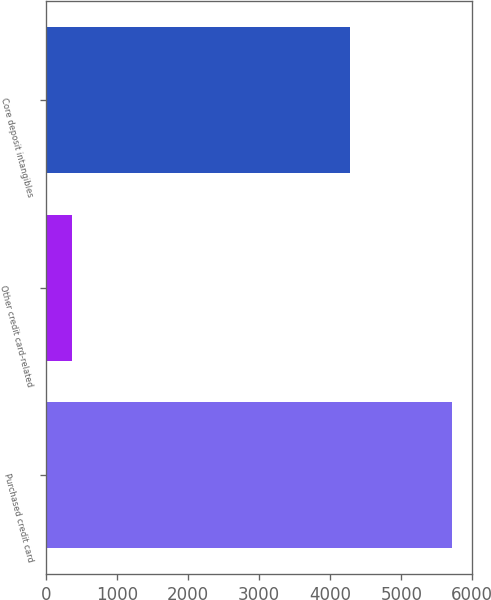Convert chart. <chart><loc_0><loc_0><loc_500><loc_500><bar_chart><fcel>Purchased credit card<fcel>Other credit card-related<fcel>Core deposit intangibles<nl><fcel>5716<fcel>367<fcel>4283<nl></chart> 